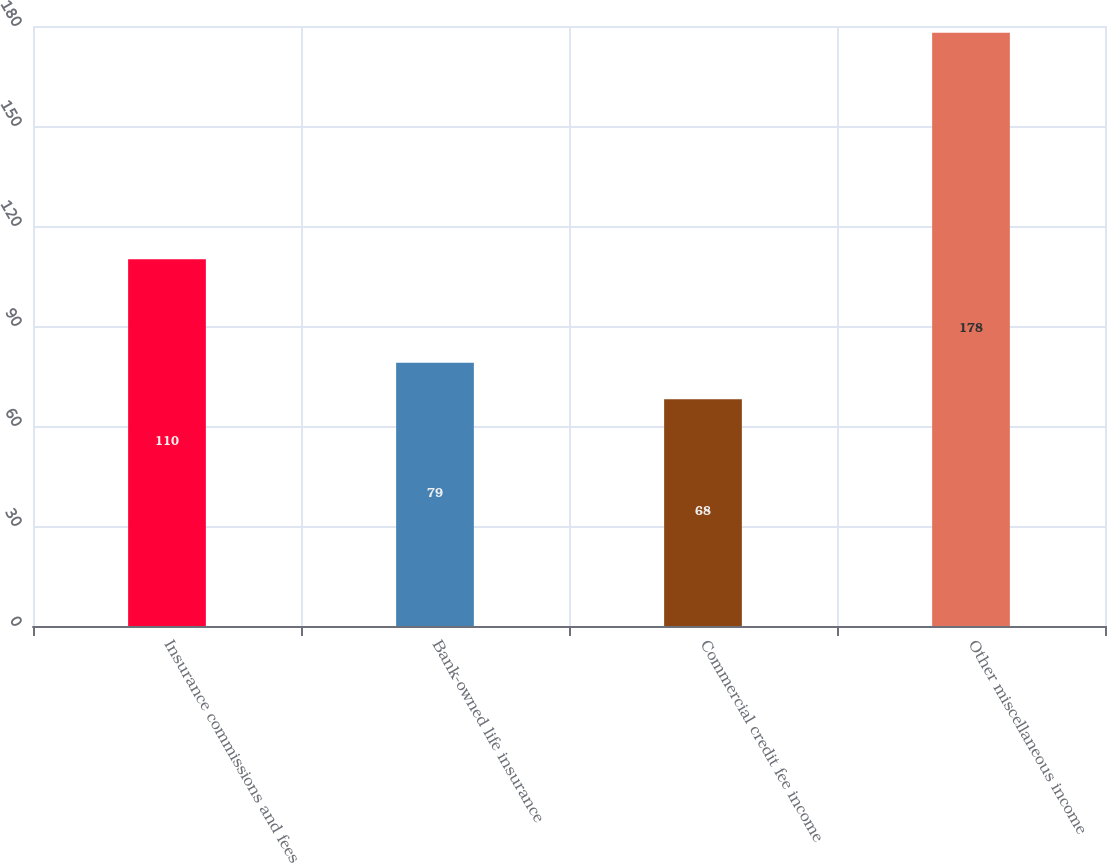Convert chart. <chart><loc_0><loc_0><loc_500><loc_500><bar_chart><fcel>Insurance commissions and fees<fcel>Bank-owned life insurance<fcel>Commercial credit fee income<fcel>Other miscellaneous income<nl><fcel>110<fcel>79<fcel>68<fcel>178<nl></chart> 